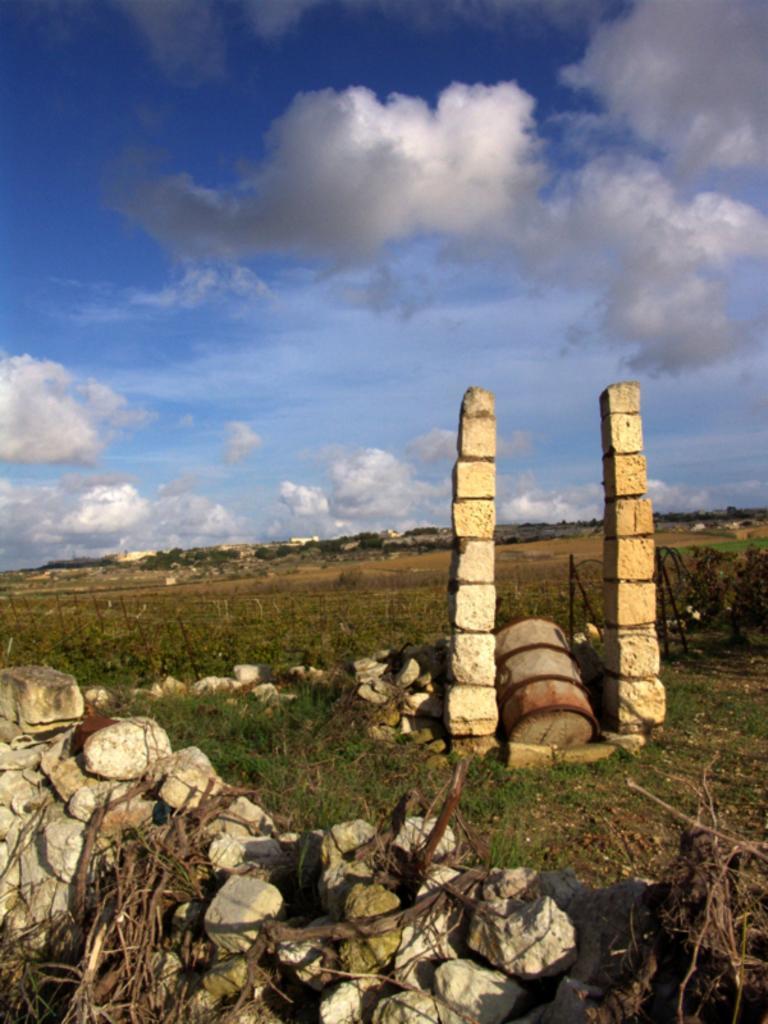Could you give a brief overview of what you see in this image? In this image I can see few stones, background I can see two pillars, grass and trees in green color and the sky is in blue and white color. 